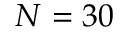Convert formula to latex. <formula><loc_0><loc_0><loc_500><loc_500>N = 3 0</formula> 